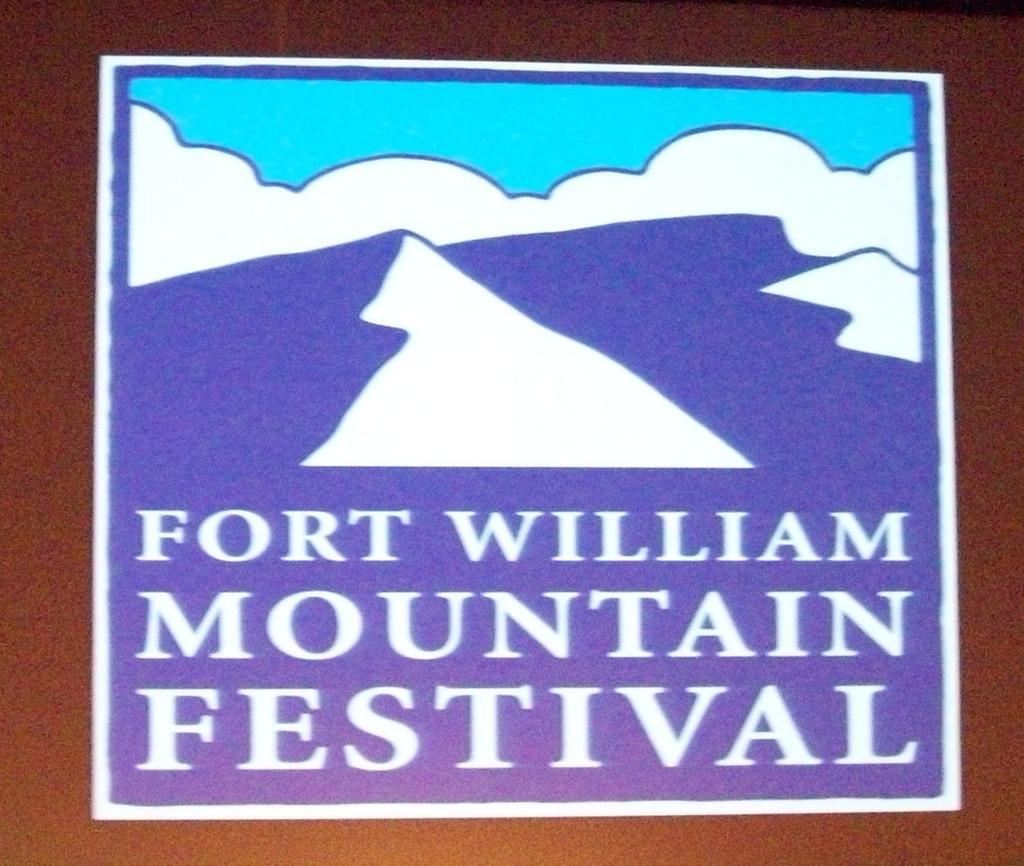<image>
Offer a succinct explanation of the picture presented. a sign that says fort william mountain festival on it 